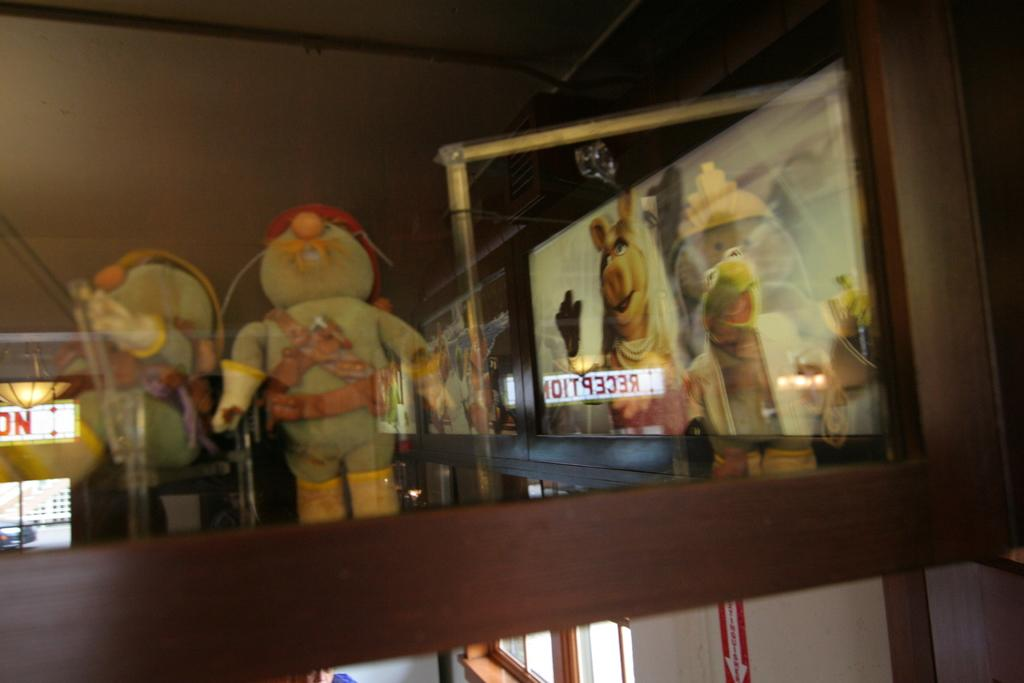Where was the image taken? The image was taken indoors. What can be seen at the bottom of the image? There is a wall with a window at the bottom of the image. What is casting shadows in the middle of the image? There are shadows of toys in the middle of the image. What else can be seen in the middle of the image? There are a few things visible in the middle of the image. What time is the police officer shown in the image? There is no police officer present in the image. What type of straw is used to stir the shadows in the image? There are no straws present in the image, as it features shadows of toys and not any liquids. 